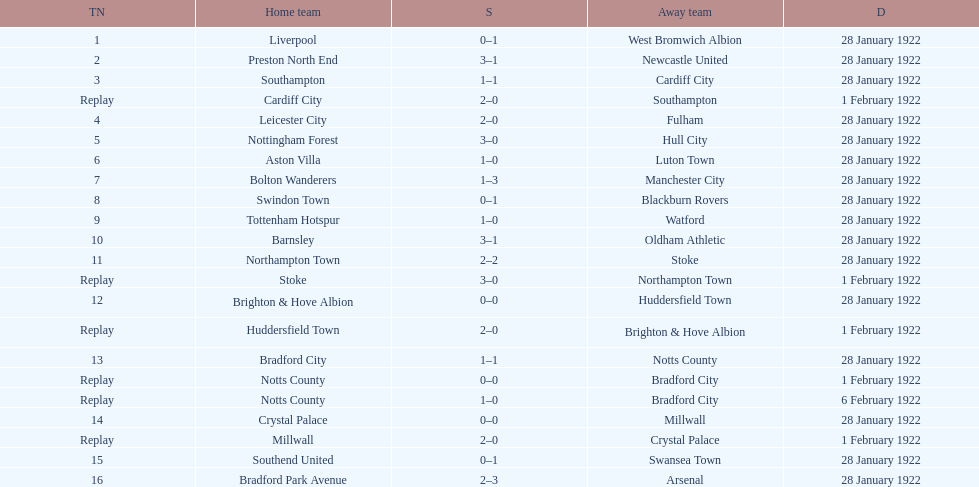What is the number of points scored on 6 february 1922? 1. 